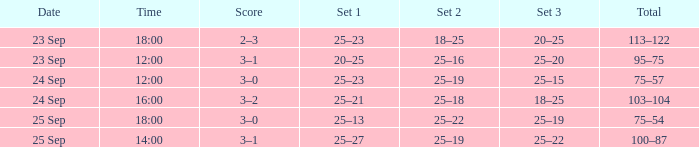What was the score when the time was 14:00? 3–1. 